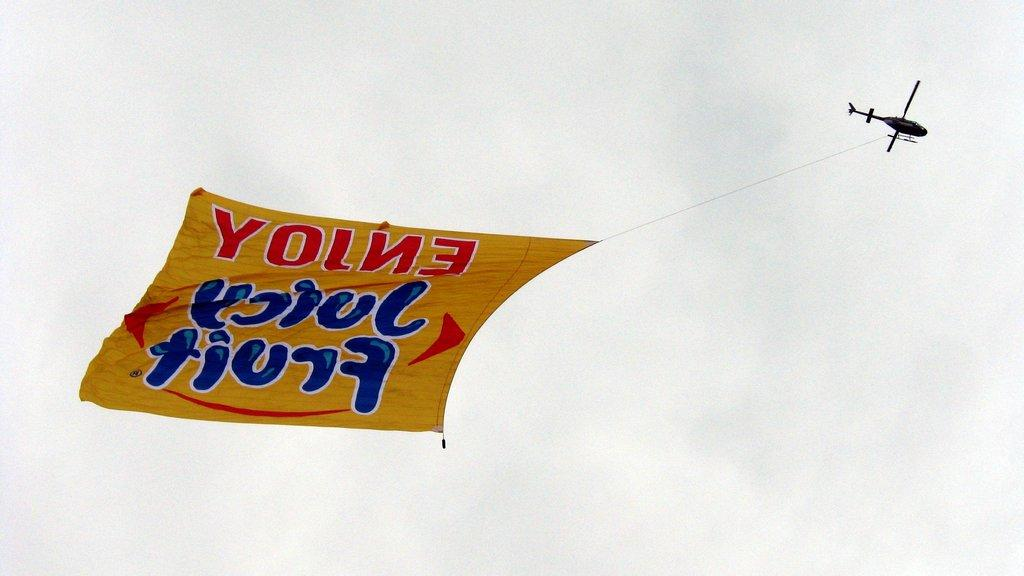What is the main subject of the image? The main subject of the image is a helicopter. What is attached to the helicopter? The helicopter has a banner attached to it. Where is the helicopter located in the image? The helicopter is flying in the sky. What type of vest is the helicopter wearing in the image? Helicopters do not wear vests, as they are machines and not living beings. 